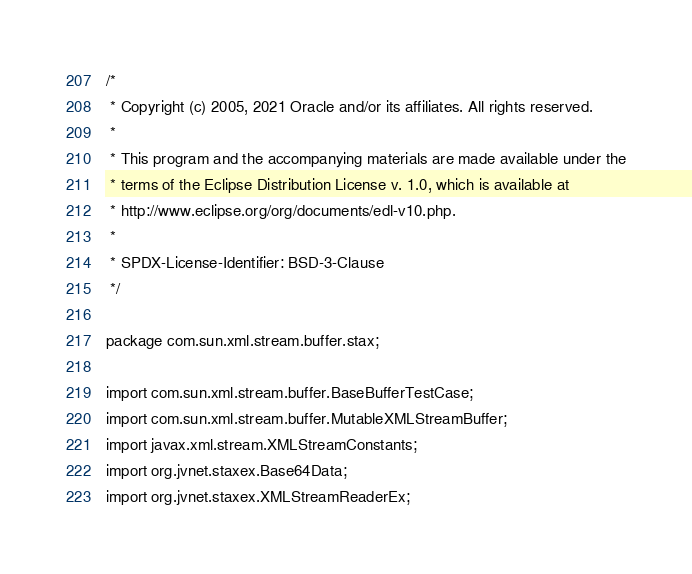Convert code to text. <code><loc_0><loc_0><loc_500><loc_500><_Java_>/*
 * Copyright (c) 2005, 2021 Oracle and/or its affiliates. All rights reserved.
 *
 * This program and the accompanying materials are made available under the
 * terms of the Eclipse Distribution License v. 1.0, which is available at
 * http://www.eclipse.org/org/documents/edl-v10.php.
 *
 * SPDX-License-Identifier: BSD-3-Clause
 */

package com.sun.xml.stream.buffer.stax;

import com.sun.xml.stream.buffer.BaseBufferTestCase;
import com.sun.xml.stream.buffer.MutableXMLStreamBuffer;
import javax.xml.stream.XMLStreamConstants;
import org.jvnet.staxex.Base64Data;
import org.jvnet.staxex.XMLStreamReaderEx;</code> 